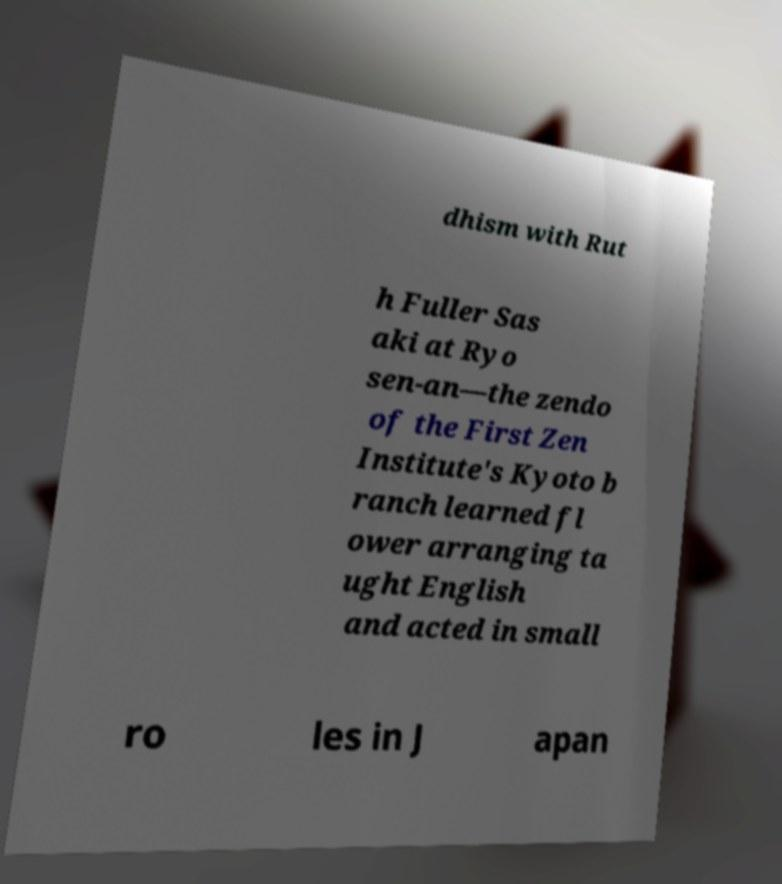Please read and relay the text visible in this image. What does it say? dhism with Rut h Fuller Sas aki at Ryo sen-an—the zendo of the First Zen Institute's Kyoto b ranch learned fl ower arranging ta ught English and acted in small ro les in J apan 